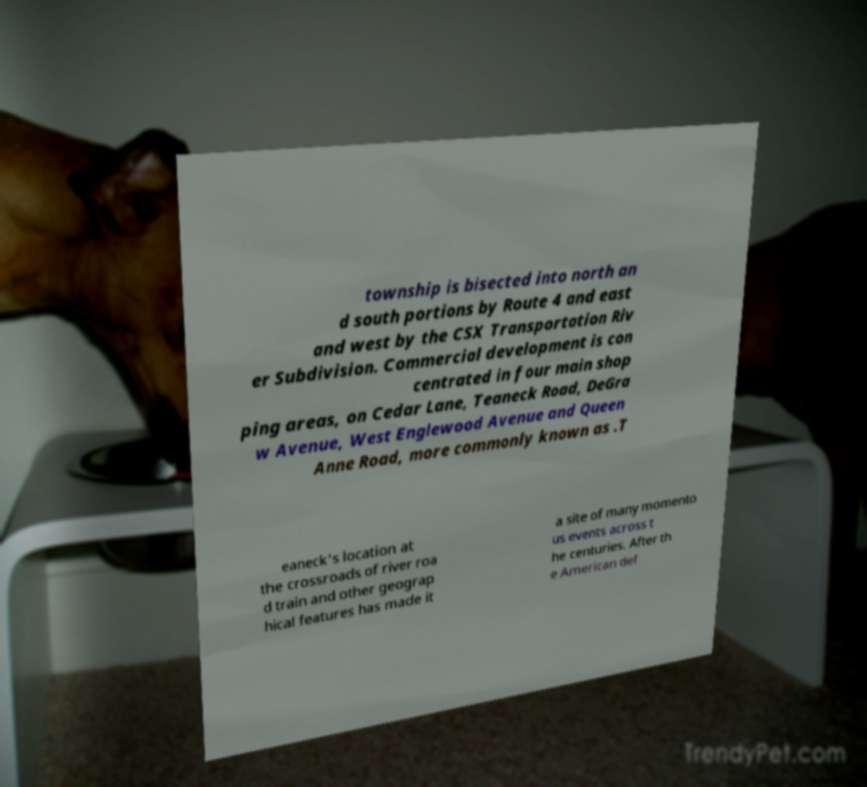What messages or text are displayed in this image? I need them in a readable, typed format. township is bisected into north an d south portions by Route 4 and east and west by the CSX Transportation Riv er Subdivision. Commercial development is con centrated in four main shop ping areas, on Cedar Lane, Teaneck Road, DeGra w Avenue, West Englewood Avenue and Queen Anne Road, more commonly known as .T eaneck's location at the crossroads of river roa d train and other geograp hical features has made it a site of many momento us events across t he centuries. After th e American def 